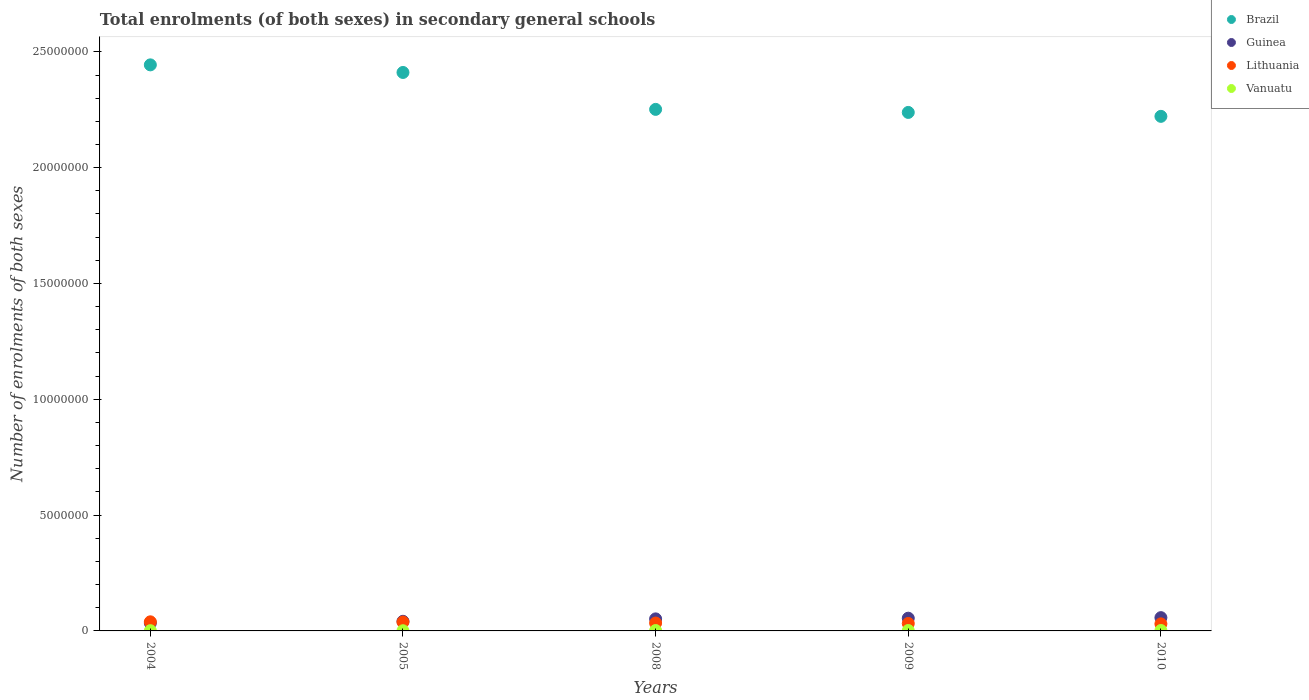How many different coloured dotlines are there?
Your answer should be very brief. 4. What is the number of enrolments in secondary schools in Brazil in 2010?
Offer a very short reply. 2.22e+07. Across all years, what is the maximum number of enrolments in secondary schools in Lithuania?
Give a very brief answer. 3.93e+05. Across all years, what is the minimum number of enrolments in secondary schools in Brazil?
Your answer should be compact. 2.22e+07. What is the total number of enrolments in secondary schools in Guinea in the graph?
Your answer should be compact. 2.40e+06. What is the difference between the number of enrolments in secondary schools in Brazil in 2008 and that in 2009?
Your answer should be compact. 1.32e+05. What is the difference between the number of enrolments in secondary schools in Vanuatu in 2004 and the number of enrolments in secondary schools in Brazil in 2009?
Your answer should be compact. -2.24e+07. What is the average number of enrolments in secondary schools in Vanuatu per year?
Provide a succinct answer. 1.43e+04. In the year 2010, what is the difference between the number of enrolments in secondary schools in Lithuania and number of enrolments in secondary schools in Brazil?
Make the answer very short. -2.19e+07. What is the ratio of the number of enrolments in secondary schools in Vanuatu in 2004 to that in 2008?
Your answer should be very brief. 0.63. What is the difference between the highest and the second highest number of enrolments in secondary schools in Lithuania?
Your response must be concise. 7868. What is the difference between the highest and the lowest number of enrolments in secondary schools in Vanuatu?
Provide a short and direct response. 1.01e+04. In how many years, is the number of enrolments in secondary schools in Brazil greater than the average number of enrolments in secondary schools in Brazil taken over all years?
Offer a terse response. 2. Is it the case that in every year, the sum of the number of enrolments in secondary schools in Vanuatu and number of enrolments in secondary schools in Brazil  is greater than the number of enrolments in secondary schools in Guinea?
Provide a succinct answer. Yes. How many dotlines are there?
Ensure brevity in your answer.  4. Are the values on the major ticks of Y-axis written in scientific E-notation?
Give a very brief answer. No. How are the legend labels stacked?
Keep it short and to the point. Vertical. What is the title of the graph?
Your answer should be compact. Total enrolments (of both sexes) in secondary general schools. Does "Jamaica" appear as one of the legend labels in the graph?
Provide a succinct answer. No. What is the label or title of the X-axis?
Give a very brief answer. Years. What is the label or title of the Y-axis?
Keep it short and to the point. Number of enrolments of both sexes. What is the Number of enrolments of both sexes of Brazil in 2004?
Your answer should be compact. 2.44e+07. What is the Number of enrolments of both sexes in Guinea in 2004?
Make the answer very short. 3.40e+05. What is the Number of enrolments of both sexes of Lithuania in 2004?
Your answer should be compact. 3.93e+05. What is the Number of enrolments of both sexes of Vanuatu in 2004?
Your answer should be compact. 1.06e+04. What is the Number of enrolments of both sexes of Brazil in 2005?
Ensure brevity in your answer.  2.41e+07. What is the Number of enrolments of both sexes in Guinea in 2005?
Make the answer very short. 4.16e+05. What is the Number of enrolments of both sexes in Lithuania in 2005?
Provide a succinct answer. 3.85e+05. What is the Number of enrolments of both sexes of Vanuatu in 2005?
Your response must be concise. 8211. What is the Number of enrolments of both sexes of Brazil in 2008?
Your response must be concise. 2.25e+07. What is the Number of enrolments of both sexes of Guinea in 2008?
Your answer should be very brief. 5.20e+05. What is the Number of enrolments of both sexes in Lithuania in 2008?
Keep it short and to the point. 3.40e+05. What is the Number of enrolments of both sexes in Vanuatu in 2008?
Ensure brevity in your answer.  1.67e+04. What is the Number of enrolments of both sexes in Brazil in 2009?
Make the answer very short. 2.24e+07. What is the Number of enrolments of both sexes in Guinea in 2009?
Your response must be concise. 5.49e+05. What is the Number of enrolments of both sexes in Lithuania in 2009?
Give a very brief answer. 3.22e+05. What is the Number of enrolments of both sexes in Vanuatu in 2009?
Provide a succinct answer. 1.79e+04. What is the Number of enrolments of both sexes of Brazil in 2010?
Offer a terse response. 2.22e+07. What is the Number of enrolments of both sexes in Guinea in 2010?
Offer a terse response. 5.73e+05. What is the Number of enrolments of both sexes in Lithuania in 2010?
Provide a succinct answer. 3.05e+05. What is the Number of enrolments of both sexes in Vanuatu in 2010?
Keep it short and to the point. 1.83e+04. Across all years, what is the maximum Number of enrolments of both sexes in Brazil?
Provide a succinct answer. 2.44e+07. Across all years, what is the maximum Number of enrolments of both sexes of Guinea?
Ensure brevity in your answer.  5.73e+05. Across all years, what is the maximum Number of enrolments of both sexes of Lithuania?
Offer a very short reply. 3.93e+05. Across all years, what is the maximum Number of enrolments of both sexes in Vanuatu?
Your answer should be very brief. 1.83e+04. Across all years, what is the minimum Number of enrolments of both sexes of Brazil?
Offer a very short reply. 2.22e+07. Across all years, what is the minimum Number of enrolments of both sexes of Guinea?
Provide a short and direct response. 3.40e+05. Across all years, what is the minimum Number of enrolments of both sexes in Lithuania?
Keep it short and to the point. 3.05e+05. Across all years, what is the minimum Number of enrolments of both sexes in Vanuatu?
Provide a succinct answer. 8211. What is the total Number of enrolments of both sexes in Brazil in the graph?
Make the answer very short. 1.16e+08. What is the total Number of enrolments of both sexes in Guinea in the graph?
Keep it short and to the point. 2.40e+06. What is the total Number of enrolments of both sexes in Lithuania in the graph?
Give a very brief answer. 1.74e+06. What is the total Number of enrolments of both sexes in Vanuatu in the graph?
Ensure brevity in your answer.  7.17e+04. What is the difference between the Number of enrolments of both sexes in Brazil in 2004 and that in 2005?
Offer a very short reply. 3.28e+05. What is the difference between the Number of enrolments of both sexes in Guinea in 2004 and that in 2005?
Ensure brevity in your answer.  -7.53e+04. What is the difference between the Number of enrolments of both sexes in Lithuania in 2004 and that in 2005?
Provide a short and direct response. 7868. What is the difference between the Number of enrolments of both sexes in Vanuatu in 2004 and that in 2005?
Your answer should be very brief. 2380. What is the difference between the Number of enrolments of both sexes of Brazil in 2004 and that in 2008?
Provide a succinct answer. 1.92e+06. What is the difference between the Number of enrolments of both sexes in Guinea in 2004 and that in 2008?
Make the answer very short. -1.79e+05. What is the difference between the Number of enrolments of both sexes of Lithuania in 2004 and that in 2008?
Provide a short and direct response. 5.35e+04. What is the difference between the Number of enrolments of both sexes in Vanuatu in 2004 and that in 2008?
Ensure brevity in your answer.  -6143. What is the difference between the Number of enrolments of both sexes in Brazil in 2004 and that in 2009?
Your response must be concise. 2.05e+06. What is the difference between the Number of enrolments of both sexes of Guinea in 2004 and that in 2009?
Give a very brief answer. -2.09e+05. What is the difference between the Number of enrolments of both sexes in Lithuania in 2004 and that in 2009?
Keep it short and to the point. 7.16e+04. What is the difference between the Number of enrolments of both sexes in Vanuatu in 2004 and that in 2009?
Give a very brief answer. -7286. What is the difference between the Number of enrolments of both sexes in Brazil in 2004 and that in 2010?
Give a very brief answer. 2.22e+06. What is the difference between the Number of enrolments of both sexes in Guinea in 2004 and that in 2010?
Offer a very short reply. -2.33e+05. What is the difference between the Number of enrolments of both sexes in Lithuania in 2004 and that in 2010?
Your answer should be very brief. 8.85e+04. What is the difference between the Number of enrolments of both sexes of Vanuatu in 2004 and that in 2010?
Give a very brief answer. -7688. What is the difference between the Number of enrolments of both sexes in Brazil in 2005 and that in 2008?
Your answer should be compact. 1.59e+06. What is the difference between the Number of enrolments of both sexes in Guinea in 2005 and that in 2008?
Ensure brevity in your answer.  -1.04e+05. What is the difference between the Number of enrolments of both sexes in Lithuania in 2005 and that in 2008?
Ensure brevity in your answer.  4.56e+04. What is the difference between the Number of enrolments of both sexes in Vanuatu in 2005 and that in 2008?
Provide a succinct answer. -8523. What is the difference between the Number of enrolments of both sexes in Brazil in 2005 and that in 2009?
Your answer should be very brief. 1.73e+06. What is the difference between the Number of enrolments of both sexes of Guinea in 2005 and that in 2009?
Your response must be concise. -1.33e+05. What is the difference between the Number of enrolments of both sexes of Lithuania in 2005 and that in 2009?
Your answer should be very brief. 6.37e+04. What is the difference between the Number of enrolments of both sexes in Vanuatu in 2005 and that in 2009?
Ensure brevity in your answer.  -9666. What is the difference between the Number of enrolments of both sexes of Brazil in 2005 and that in 2010?
Offer a terse response. 1.89e+06. What is the difference between the Number of enrolments of both sexes in Guinea in 2005 and that in 2010?
Offer a terse response. -1.57e+05. What is the difference between the Number of enrolments of both sexes of Lithuania in 2005 and that in 2010?
Your response must be concise. 8.07e+04. What is the difference between the Number of enrolments of both sexes in Vanuatu in 2005 and that in 2010?
Make the answer very short. -1.01e+04. What is the difference between the Number of enrolments of both sexes in Brazil in 2008 and that in 2009?
Your answer should be compact. 1.32e+05. What is the difference between the Number of enrolments of both sexes of Guinea in 2008 and that in 2009?
Your response must be concise. -2.94e+04. What is the difference between the Number of enrolments of both sexes of Lithuania in 2008 and that in 2009?
Make the answer very short. 1.81e+04. What is the difference between the Number of enrolments of both sexes of Vanuatu in 2008 and that in 2009?
Provide a succinct answer. -1143. What is the difference between the Number of enrolments of both sexes in Brazil in 2008 and that in 2010?
Provide a short and direct response. 3.01e+05. What is the difference between the Number of enrolments of both sexes of Guinea in 2008 and that in 2010?
Give a very brief answer. -5.35e+04. What is the difference between the Number of enrolments of both sexes of Lithuania in 2008 and that in 2010?
Keep it short and to the point. 3.50e+04. What is the difference between the Number of enrolments of both sexes of Vanuatu in 2008 and that in 2010?
Give a very brief answer. -1545. What is the difference between the Number of enrolments of both sexes of Brazil in 2009 and that in 2010?
Ensure brevity in your answer.  1.69e+05. What is the difference between the Number of enrolments of both sexes in Guinea in 2009 and that in 2010?
Your answer should be very brief. -2.40e+04. What is the difference between the Number of enrolments of both sexes of Lithuania in 2009 and that in 2010?
Your response must be concise. 1.69e+04. What is the difference between the Number of enrolments of both sexes of Vanuatu in 2009 and that in 2010?
Ensure brevity in your answer.  -402. What is the difference between the Number of enrolments of both sexes of Brazil in 2004 and the Number of enrolments of both sexes of Guinea in 2005?
Your answer should be very brief. 2.40e+07. What is the difference between the Number of enrolments of both sexes in Brazil in 2004 and the Number of enrolments of both sexes in Lithuania in 2005?
Your answer should be compact. 2.41e+07. What is the difference between the Number of enrolments of both sexes in Brazil in 2004 and the Number of enrolments of both sexes in Vanuatu in 2005?
Ensure brevity in your answer.  2.44e+07. What is the difference between the Number of enrolments of both sexes of Guinea in 2004 and the Number of enrolments of both sexes of Lithuania in 2005?
Your answer should be compact. -4.48e+04. What is the difference between the Number of enrolments of both sexes in Guinea in 2004 and the Number of enrolments of both sexes in Vanuatu in 2005?
Give a very brief answer. 3.32e+05. What is the difference between the Number of enrolments of both sexes in Lithuania in 2004 and the Number of enrolments of both sexes in Vanuatu in 2005?
Your response must be concise. 3.85e+05. What is the difference between the Number of enrolments of both sexes of Brazil in 2004 and the Number of enrolments of both sexes of Guinea in 2008?
Offer a very short reply. 2.39e+07. What is the difference between the Number of enrolments of both sexes in Brazil in 2004 and the Number of enrolments of both sexes in Lithuania in 2008?
Provide a succinct answer. 2.41e+07. What is the difference between the Number of enrolments of both sexes of Brazil in 2004 and the Number of enrolments of both sexes of Vanuatu in 2008?
Your response must be concise. 2.44e+07. What is the difference between the Number of enrolments of both sexes of Guinea in 2004 and the Number of enrolments of both sexes of Lithuania in 2008?
Offer a very short reply. 788. What is the difference between the Number of enrolments of both sexes of Guinea in 2004 and the Number of enrolments of both sexes of Vanuatu in 2008?
Your answer should be very brief. 3.24e+05. What is the difference between the Number of enrolments of both sexes of Lithuania in 2004 and the Number of enrolments of both sexes of Vanuatu in 2008?
Offer a terse response. 3.76e+05. What is the difference between the Number of enrolments of both sexes in Brazil in 2004 and the Number of enrolments of both sexes in Guinea in 2009?
Give a very brief answer. 2.39e+07. What is the difference between the Number of enrolments of both sexes in Brazil in 2004 and the Number of enrolments of both sexes in Lithuania in 2009?
Make the answer very short. 2.41e+07. What is the difference between the Number of enrolments of both sexes of Brazil in 2004 and the Number of enrolments of both sexes of Vanuatu in 2009?
Your response must be concise. 2.44e+07. What is the difference between the Number of enrolments of both sexes of Guinea in 2004 and the Number of enrolments of both sexes of Lithuania in 2009?
Ensure brevity in your answer.  1.89e+04. What is the difference between the Number of enrolments of both sexes in Guinea in 2004 and the Number of enrolments of both sexes in Vanuatu in 2009?
Your answer should be compact. 3.23e+05. What is the difference between the Number of enrolments of both sexes in Lithuania in 2004 and the Number of enrolments of both sexes in Vanuatu in 2009?
Your answer should be very brief. 3.75e+05. What is the difference between the Number of enrolments of both sexes in Brazil in 2004 and the Number of enrolments of both sexes in Guinea in 2010?
Keep it short and to the point. 2.39e+07. What is the difference between the Number of enrolments of both sexes in Brazil in 2004 and the Number of enrolments of both sexes in Lithuania in 2010?
Your answer should be very brief. 2.41e+07. What is the difference between the Number of enrolments of both sexes of Brazil in 2004 and the Number of enrolments of both sexes of Vanuatu in 2010?
Offer a very short reply. 2.44e+07. What is the difference between the Number of enrolments of both sexes in Guinea in 2004 and the Number of enrolments of both sexes in Lithuania in 2010?
Offer a very short reply. 3.58e+04. What is the difference between the Number of enrolments of both sexes of Guinea in 2004 and the Number of enrolments of both sexes of Vanuatu in 2010?
Offer a very short reply. 3.22e+05. What is the difference between the Number of enrolments of both sexes of Lithuania in 2004 and the Number of enrolments of both sexes of Vanuatu in 2010?
Give a very brief answer. 3.75e+05. What is the difference between the Number of enrolments of both sexes in Brazil in 2005 and the Number of enrolments of both sexes in Guinea in 2008?
Your answer should be compact. 2.36e+07. What is the difference between the Number of enrolments of both sexes in Brazil in 2005 and the Number of enrolments of both sexes in Lithuania in 2008?
Your answer should be very brief. 2.38e+07. What is the difference between the Number of enrolments of both sexes in Brazil in 2005 and the Number of enrolments of both sexes in Vanuatu in 2008?
Your response must be concise. 2.41e+07. What is the difference between the Number of enrolments of both sexes in Guinea in 2005 and the Number of enrolments of both sexes in Lithuania in 2008?
Make the answer very short. 7.61e+04. What is the difference between the Number of enrolments of both sexes of Guinea in 2005 and the Number of enrolments of both sexes of Vanuatu in 2008?
Give a very brief answer. 3.99e+05. What is the difference between the Number of enrolments of both sexes in Lithuania in 2005 and the Number of enrolments of both sexes in Vanuatu in 2008?
Your answer should be very brief. 3.69e+05. What is the difference between the Number of enrolments of both sexes in Brazil in 2005 and the Number of enrolments of both sexes in Guinea in 2009?
Keep it short and to the point. 2.36e+07. What is the difference between the Number of enrolments of both sexes of Brazil in 2005 and the Number of enrolments of both sexes of Lithuania in 2009?
Provide a short and direct response. 2.38e+07. What is the difference between the Number of enrolments of both sexes of Brazil in 2005 and the Number of enrolments of both sexes of Vanuatu in 2009?
Offer a terse response. 2.41e+07. What is the difference between the Number of enrolments of both sexes of Guinea in 2005 and the Number of enrolments of both sexes of Lithuania in 2009?
Give a very brief answer. 9.42e+04. What is the difference between the Number of enrolments of both sexes of Guinea in 2005 and the Number of enrolments of both sexes of Vanuatu in 2009?
Provide a succinct answer. 3.98e+05. What is the difference between the Number of enrolments of both sexes of Lithuania in 2005 and the Number of enrolments of both sexes of Vanuatu in 2009?
Keep it short and to the point. 3.67e+05. What is the difference between the Number of enrolments of both sexes in Brazil in 2005 and the Number of enrolments of both sexes in Guinea in 2010?
Offer a terse response. 2.35e+07. What is the difference between the Number of enrolments of both sexes in Brazil in 2005 and the Number of enrolments of both sexes in Lithuania in 2010?
Your response must be concise. 2.38e+07. What is the difference between the Number of enrolments of both sexes of Brazil in 2005 and the Number of enrolments of both sexes of Vanuatu in 2010?
Keep it short and to the point. 2.41e+07. What is the difference between the Number of enrolments of both sexes in Guinea in 2005 and the Number of enrolments of both sexes in Lithuania in 2010?
Keep it short and to the point. 1.11e+05. What is the difference between the Number of enrolments of both sexes of Guinea in 2005 and the Number of enrolments of both sexes of Vanuatu in 2010?
Your answer should be very brief. 3.97e+05. What is the difference between the Number of enrolments of both sexes in Lithuania in 2005 and the Number of enrolments of both sexes in Vanuatu in 2010?
Provide a short and direct response. 3.67e+05. What is the difference between the Number of enrolments of both sexes in Brazil in 2008 and the Number of enrolments of both sexes in Guinea in 2009?
Offer a terse response. 2.20e+07. What is the difference between the Number of enrolments of both sexes in Brazil in 2008 and the Number of enrolments of both sexes in Lithuania in 2009?
Your answer should be compact. 2.22e+07. What is the difference between the Number of enrolments of both sexes in Brazil in 2008 and the Number of enrolments of both sexes in Vanuatu in 2009?
Keep it short and to the point. 2.25e+07. What is the difference between the Number of enrolments of both sexes of Guinea in 2008 and the Number of enrolments of both sexes of Lithuania in 2009?
Provide a short and direct response. 1.98e+05. What is the difference between the Number of enrolments of both sexes in Guinea in 2008 and the Number of enrolments of both sexes in Vanuatu in 2009?
Make the answer very short. 5.02e+05. What is the difference between the Number of enrolments of both sexes of Lithuania in 2008 and the Number of enrolments of both sexes of Vanuatu in 2009?
Give a very brief answer. 3.22e+05. What is the difference between the Number of enrolments of both sexes in Brazil in 2008 and the Number of enrolments of both sexes in Guinea in 2010?
Provide a succinct answer. 2.19e+07. What is the difference between the Number of enrolments of both sexes in Brazil in 2008 and the Number of enrolments of both sexes in Lithuania in 2010?
Provide a short and direct response. 2.22e+07. What is the difference between the Number of enrolments of both sexes in Brazil in 2008 and the Number of enrolments of both sexes in Vanuatu in 2010?
Your answer should be compact. 2.25e+07. What is the difference between the Number of enrolments of both sexes of Guinea in 2008 and the Number of enrolments of both sexes of Lithuania in 2010?
Offer a very short reply. 2.15e+05. What is the difference between the Number of enrolments of both sexes of Guinea in 2008 and the Number of enrolments of both sexes of Vanuatu in 2010?
Provide a succinct answer. 5.01e+05. What is the difference between the Number of enrolments of both sexes in Lithuania in 2008 and the Number of enrolments of both sexes in Vanuatu in 2010?
Your response must be concise. 3.21e+05. What is the difference between the Number of enrolments of both sexes in Brazil in 2009 and the Number of enrolments of both sexes in Guinea in 2010?
Provide a succinct answer. 2.18e+07. What is the difference between the Number of enrolments of both sexes of Brazil in 2009 and the Number of enrolments of both sexes of Lithuania in 2010?
Your response must be concise. 2.21e+07. What is the difference between the Number of enrolments of both sexes in Brazil in 2009 and the Number of enrolments of both sexes in Vanuatu in 2010?
Ensure brevity in your answer.  2.24e+07. What is the difference between the Number of enrolments of both sexes in Guinea in 2009 and the Number of enrolments of both sexes in Lithuania in 2010?
Offer a terse response. 2.45e+05. What is the difference between the Number of enrolments of both sexes in Guinea in 2009 and the Number of enrolments of both sexes in Vanuatu in 2010?
Make the answer very short. 5.31e+05. What is the difference between the Number of enrolments of both sexes of Lithuania in 2009 and the Number of enrolments of both sexes of Vanuatu in 2010?
Your response must be concise. 3.03e+05. What is the average Number of enrolments of both sexes of Brazil per year?
Your answer should be very brief. 2.31e+07. What is the average Number of enrolments of both sexes of Guinea per year?
Provide a succinct answer. 4.80e+05. What is the average Number of enrolments of both sexes of Lithuania per year?
Your response must be concise. 3.49e+05. What is the average Number of enrolments of both sexes in Vanuatu per year?
Provide a succinct answer. 1.43e+04. In the year 2004, what is the difference between the Number of enrolments of both sexes of Brazil and Number of enrolments of both sexes of Guinea?
Your answer should be very brief. 2.41e+07. In the year 2004, what is the difference between the Number of enrolments of both sexes of Brazil and Number of enrolments of both sexes of Lithuania?
Give a very brief answer. 2.40e+07. In the year 2004, what is the difference between the Number of enrolments of both sexes in Brazil and Number of enrolments of both sexes in Vanuatu?
Your answer should be compact. 2.44e+07. In the year 2004, what is the difference between the Number of enrolments of both sexes in Guinea and Number of enrolments of both sexes in Lithuania?
Ensure brevity in your answer.  -5.27e+04. In the year 2004, what is the difference between the Number of enrolments of both sexes in Guinea and Number of enrolments of both sexes in Vanuatu?
Your response must be concise. 3.30e+05. In the year 2004, what is the difference between the Number of enrolments of both sexes in Lithuania and Number of enrolments of both sexes in Vanuatu?
Ensure brevity in your answer.  3.83e+05. In the year 2005, what is the difference between the Number of enrolments of both sexes in Brazil and Number of enrolments of both sexes in Guinea?
Your answer should be compact. 2.37e+07. In the year 2005, what is the difference between the Number of enrolments of both sexes of Brazil and Number of enrolments of both sexes of Lithuania?
Your response must be concise. 2.37e+07. In the year 2005, what is the difference between the Number of enrolments of both sexes in Brazil and Number of enrolments of both sexes in Vanuatu?
Provide a short and direct response. 2.41e+07. In the year 2005, what is the difference between the Number of enrolments of both sexes of Guinea and Number of enrolments of both sexes of Lithuania?
Ensure brevity in your answer.  3.05e+04. In the year 2005, what is the difference between the Number of enrolments of both sexes of Guinea and Number of enrolments of both sexes of Vanuatu?
Provide a short and direct response. 4.08e+05. In the year 2005, what is the difference between the Number of enrolments of both sexes in Lithuania and Number of enrolments of both sexes in Vanuatu?
Give a very brief answer. 3.77e+05. In the year 2008, what is the difference between the Number of enrolments of both sexes in Brazil and Number of enrolments of both sexes in Guinea?
Ensure brevity in your answer.  2.20e+07. In the year 2008, what is the difference between the Number of enrolments of both sexes in Brazil and Number of enrolments of both sexes in Lithuania?
Your response must be concise. 2.22e+07. In the year 2008, what is the difference between the Number of enrolments of both sexes in Brazil and Number of enrolments of both sexes in Vanuatu?
Provide a short and direct response. 2.25e+07. In the year 2008, what is the difference between the Number of enrolments of both sexes of Guinea and Number of enrolments of both sexes of Lithuania?
Your response must be concise. 1.80e+05. In the year 2008, what is the difference between the Number of enrolments of both sexes in Guinea and Number of enrolments of both sexes in Vanuatu?
Provide a succinct answer. 5.03e+05. In the year 2008, what is the difference between the Number of enrolments of both sexes in Lithuania and Number of enrolments of both sexes in Vanuatu?
Make the answer very short. 3.23e+05. In the year 2009, what is the difference between the Number of enrolments of both sexes in Brazil and Number of enrolments of both sexes in Guinea?
Make the answer very short. 2.18e+07. In the year 2009, what is the difference between the Number of enrolments of both sexes in Brazil and Number of enrolments of both sexes in Lithuania?
Your answer should be compact. 2.21e+07. In the year 2009, what is the difference between the Number of enrolments of both sexes in Brazil and Number of enrolments of both sexes in Vanuatu?
Provide a succinct answer. 2.24e+07. In the year 2009, what is the difference between the Number of enrolments of both sexes in Guinea and Number of enrolments of both sexes in Lithuania?
Give a very brief answer. 2.28e+05. In the year 2009, what is the difference between the Number of enrolments of both sexes of Guinea and Number of enrolments of both sexes of Vanuatu?
Offer a terse response. 5.31e+05. In the year 2009, what is the difference between the Number of enrolments of both sexes of Lithuania and Number of enrolments of both sexes of Vanuatu?
Provide a succinct answer. 3.04e+05. In the year 2010, what is the difference between the Number of enrolments of both sexes of Brazil and Number of enrolments of both sexes of Guinea?
Your answer should be very brief. 2.16e+07. In the year 2010, what is the difference between the Number of enrolments of both sexes in Brazil and Number of enrolments of both sexes in Lithuania?
Give a very brief answer. 2.19e+07. In the year 2010, what is the difference between the Number of enrolments of both sexes of Brazil and Number of enrolments of both sexes of Vanuatu?
Provide a succinct answer. 2.22e+07. In the year 2010, what is the difference between the Number of enrolments of both sexes of Guinea and Number of enrolments of both sexes of Lithuania?
Offer a terse response. 2.69e+05. In the year 2010, what is the difference between the Number of enrolments of both sexes of Guinea and Number of enrolments of both sexes of Vanuatu?
Offer a terse response. 5.55e+05. In the year 2010, what is the difference between the Number of enrolments of both sexes of Lithuania and Number of enrolments of both sexes of Vanuatu?
Provide a succinct answer. 2.86e+05. What is the ratio of the Number of enrolments of both sexes of Brazil in 2004 to that in 2005?
Provide a succinct answer. 1.01. What is the ratio of the Number of enrolments of both sexes in Guinea in 2004 to that in 2005?
Offer a very short reply. 0.82. What is the ratio of the Number of enrolments of both sexes in Lithuania in 2004 to that in 2005?
Provide a short and direct response. 1.02. What is the ratio of the Number of enrolments of both sexes in Vanuatu in 2004 to that in 2005?
Your response must be concise. 1.29. What is the ratio of the Number of enrolments of both sexes in Brazil in 2004 to that in 2008?
Your answer should be very brief. 1.09. What is the ratio of the Number of enrolments of both sexes in Guinea in 2004 to that in 2008?
Your answer should be very brief. 0.66. What is the ratio of the Number of enrolments of both sexes in Lithuania in 2004 to that in 2008?
Offer a terse response. 1.16. What is the ratio of the Number of enrolments of both sexes of Vanuatu in 2004 to that in 2008?
Keep it short and to the point. 0.63. What is the ratio of the Number of enrolments of both sexes in Brazil in 2004 to that in 2009?
Provide a short and direct response. 1.09. What is the ratio of the Number of enrolments of both sexes of Guinea in 2004 to that in 2009?
Offer a very short reply. 0.62. What is the ratio of the Number of enrolments of both sexes of Lithuania in 2004 to that in 2009?
Your answer should be very brief. 1.22. What is the ratio of the Number of enrolments of both sexes of Vanuatu in 2004 to that in 2009?
Give a very brief answer. 0.59. What is the ratio of the Number of enrolments of both sexes of Brazil in 2004 to that in 2010?
Make the answer very short. 1.1. What is the ratio of the Number of enrolments of both sexes in Guinea in 2004 to that in 2010?
Offer a very short reply. 0.59. What is the ratio of the Number of enrolments of both sexes in Lithuania in 2004 to that in 2010?
Ensure brevity in your answer.  1.29. What is the ratio of the Number of enrolments of both sexes of Vanuatu in 2004 to that in 2010?
Provide a succinct answer. 0.58. What is the ratio of the Number of enrolments of both sexes in Brazil in 2005 to that in 2008?
Offer a very short reply. 1.07. What is the ratio of the Number of enrolments of both sexes of Guinea in 2005 to that in 2008?
Offer a very short reply. 0.8. What is the ratio of the Number of enrolments of both sexes in Lithuania in 2005 to that in 2008?
Provide a succinct answer. 1.13. What is the ratio of the Number of enrolments of both sexes in Vanuatu in 2005 to that in 2008?
Give a very brief answer. 0.49. What is the ratio of the Number of enrolments of both sexes of Brazil in 2005 to that in 2009?
Provide a succinct answer. 1.08. What is the ratio of the Number of enrolments of both sexes of Guinea in 2005 to that in 2009?
Ensure brevity in your answer.  0.76. What is the ratio of the Number of enrolments of both sexes in Lithuania in 2005 to that in 2009?
Your answer should be very brief. 1.2. What is the ratio of the Number of enrolments of both sexes of Vanuatu in 2005 to that in 2009?
Make the answer very short. 0.46. What is the ratio of the Number of enrolments of both sexes in Brazil in 2005 to that in 2010?
Provide a succinct answer. 1.09. What is the ratio of the Number of enrolments of both sexes of Guinea in 2005 to that in 2010?
Ensure brevity in your answer.  0.73. What is the ratio of the Number of enrolments of both sexes of Lithuania in 2005 to that in 2010?
Provide a short and direct response. 1.26. What is the ratio of the Number of enrolments of both sexes of Vanuatu in 2005 to that in 2010?
Keep it short and to the point. 0.45. What is the ratio of the Number of enrolments of both sexes in Brazil in 2008 to that in 2009?
Keep it short and to the point. 1.01. What is the ratio of the Number of enrolments of both sexes of Guinea in 2008 to that in 2009?
Ensure brevity in your answer.  0.95. What is the ratio of the Number of enrolments of both sexes in Lithuania in 2008 to that in 2009?
Your response must be concise. 1.06. What is the ratio of the Number of enrolments of both sexes in Vanuatu in 2008 to that in 2009?
Keep it short and to the point. 0.94. What is the ratio of the Number of enrolments of both sexes of Brazil in 2008 to that in 2010?
Your answer should be compact. 1.01. What is the ratio of the Number of enrolments of both sexes in Guinea in 2008 to that in 2010?
Keep it short and to the point. 0.91. What is the ratio of the Number of enrolments of both sexes in Lithuania in 2008 to that in 2010?
Offer a very short reply. 1.11. What is the ratio of the Number of enrolments of both sexes of Vanuatu in 2008 to that in 2010?
Make the answer very short. 0.92. What is the ratio of the Number of enrolments of both sexes of Brazil in 2009 to that in 2010?
Offer a terse response. 1.01. What is the ratio of the Number of enrolments of both sexes in Guinea in 2009 to that in 2010?
Offer a very short reply. 0.96. What is the ratio of the Number of enrolments of both sexes in Lithuania in 2009 to that in 2010?
Provide a succinct answer. 1.06. What is the ratio of the Number of enrolments of both sexes of Vanuatu in 2009 to that in 2010?
Give a very brief answer. 0.98. What is the difference between the highest and the second highest Number of enrolments of both sexes in Brazil?
Give a very brief answer. 3.28e+05. What is the difference between the highest and the second highest Number of enrolments of both sexes of Guinea?
Offer a terse response. 2.40e+04. What is the difference between the highest and the second highest Number of enrolments of both sexes in Lithuania?
Keep it short and to the point. 7868. What is the difference between the highest and the second highest Number of enrolments of both sexes in Vanuatu?
Offer a very short reply. 402. What is the difference between the highest and the lowest Number of enrolments of both sexes of Brazil?
Provide a succinct answer. 2.22e+06. What is the difference between the highest and the lowest Number of enrolments of both sexes in Guinea?
Provide a succinct answer. 2.33e+05. What is the difference between the highest and the lowest Number of enrolments of both sexes of Lithuania?
Your response must be concise. 8.85e+04. What is the difference between the highest and the lowest Number of enrolments of both sexes in Vanuatu?
Give a very brief answer. 1.01e+04. 